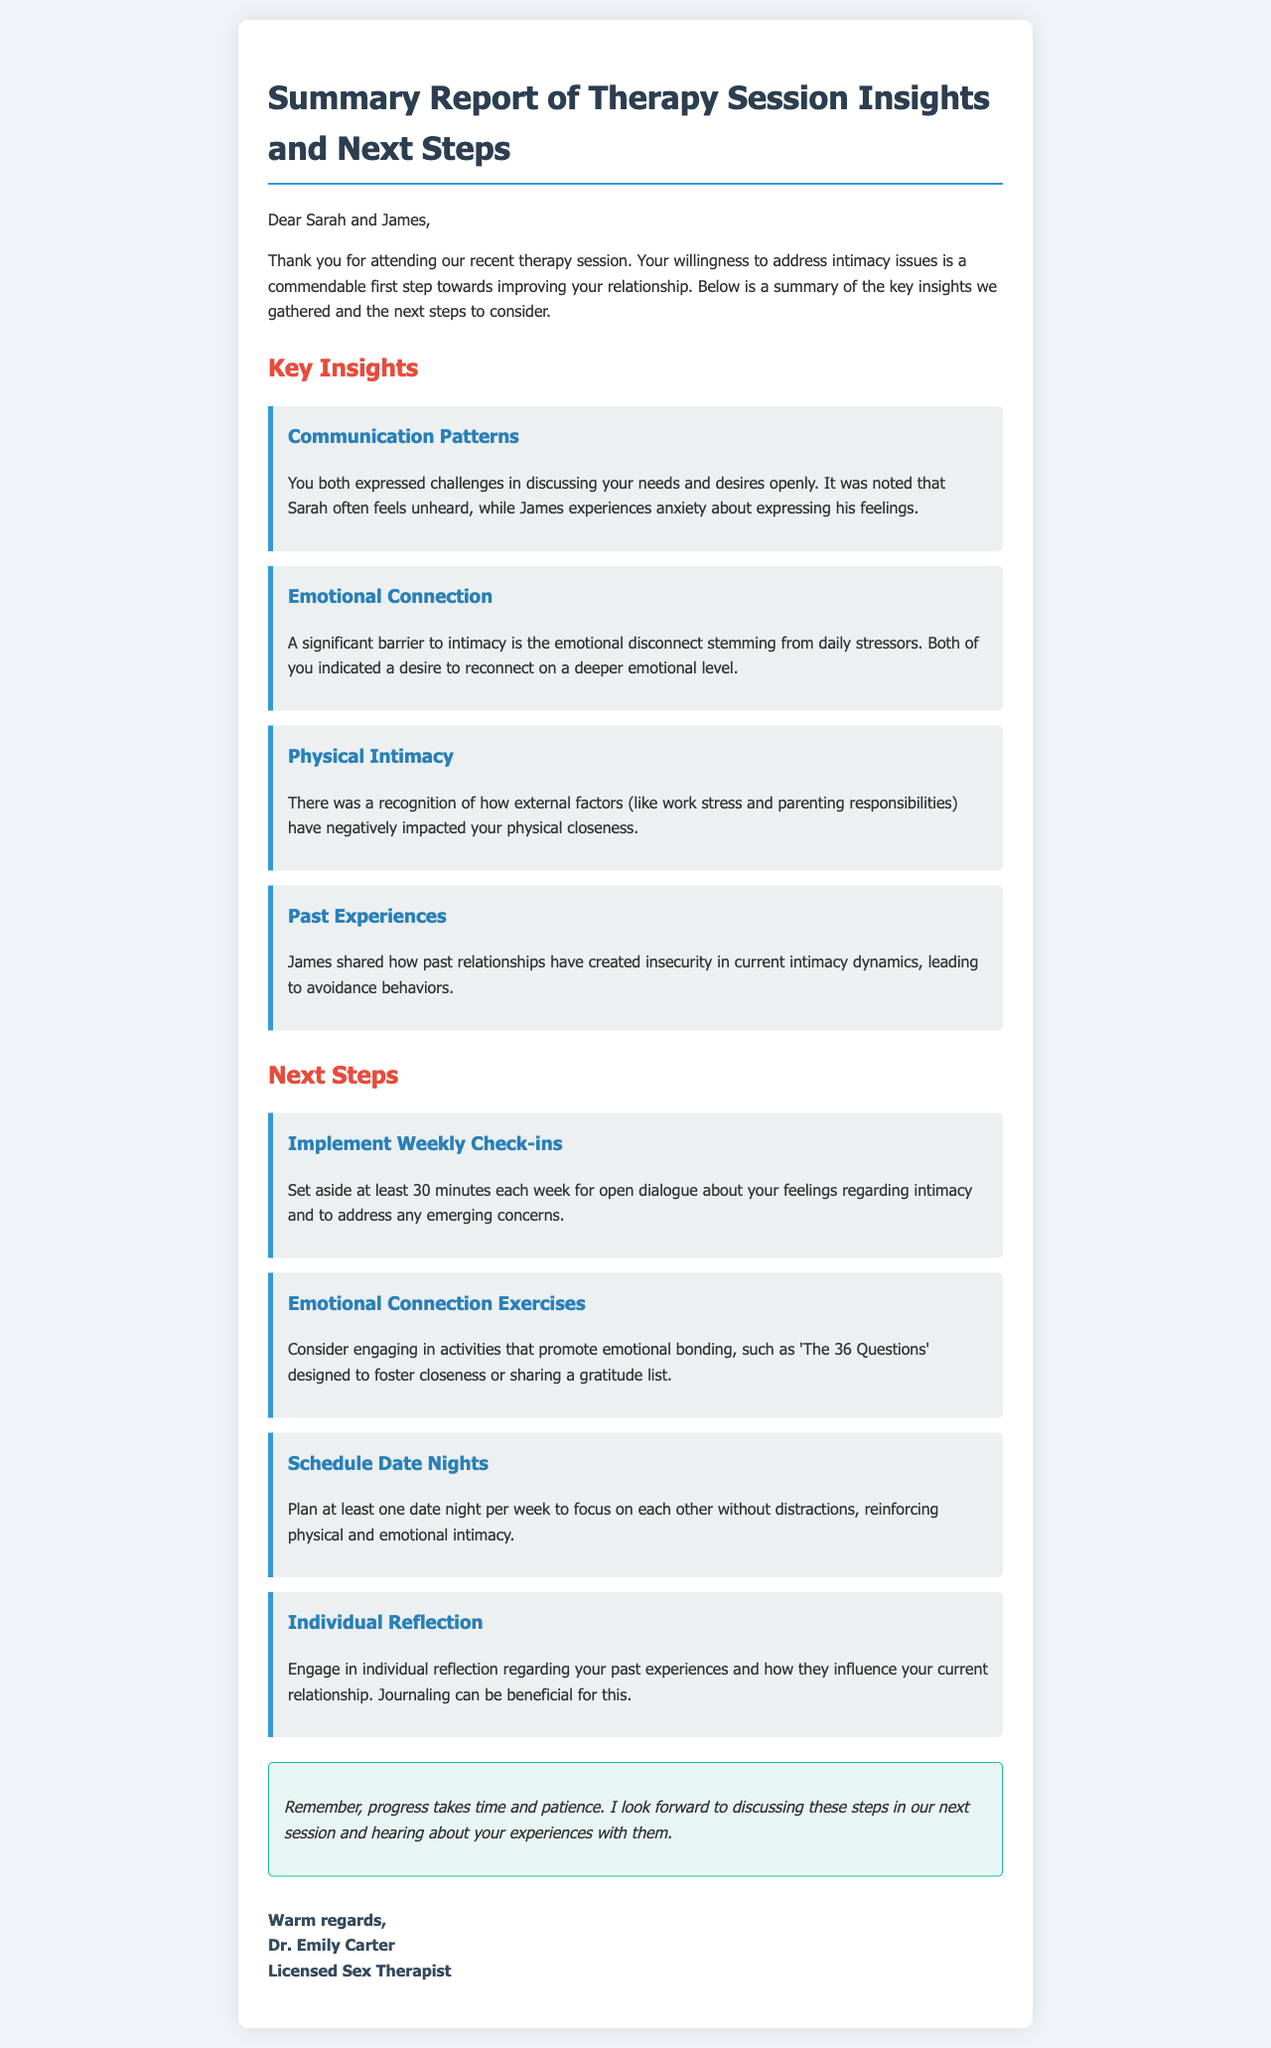What are the names of the couple? The names of the couple are mentioned at the beginning of the document as Sarah and James.
Answer: Sarah and James Who wrote the summary report? The document specifies the author's name and title in the signature section.
Answer: Dr. Emily Carter What is one suggested activity for emotional bonding? The report lists several activities under the next steps, one of which is 'The 36 Questions.'
Answer: The 36 Questions How often should the couple have their check-ins? The document recommends a specific frequency for the check-ins in the next steps section.
Answer: Weekly What is one identified barrier to intimacy? The insights section provides various barriers; one key barrier is the emotional disconnect.
Answer: Emotional disconnect How long should the weekly check-ins last? The duration for the weekly check-ins is specified clearly in the next steps section.
Answer: 30 minutes What is a consequence of James' past experiences? The insights section describes the impact of James' past relationships on current intimacy dynamics.
Answer: Insecurity What is the concluding sentiment of the report? The conclusion section reflects the therapist's encouraging outlook towards progress.
Answer: Progress takes time and patience 